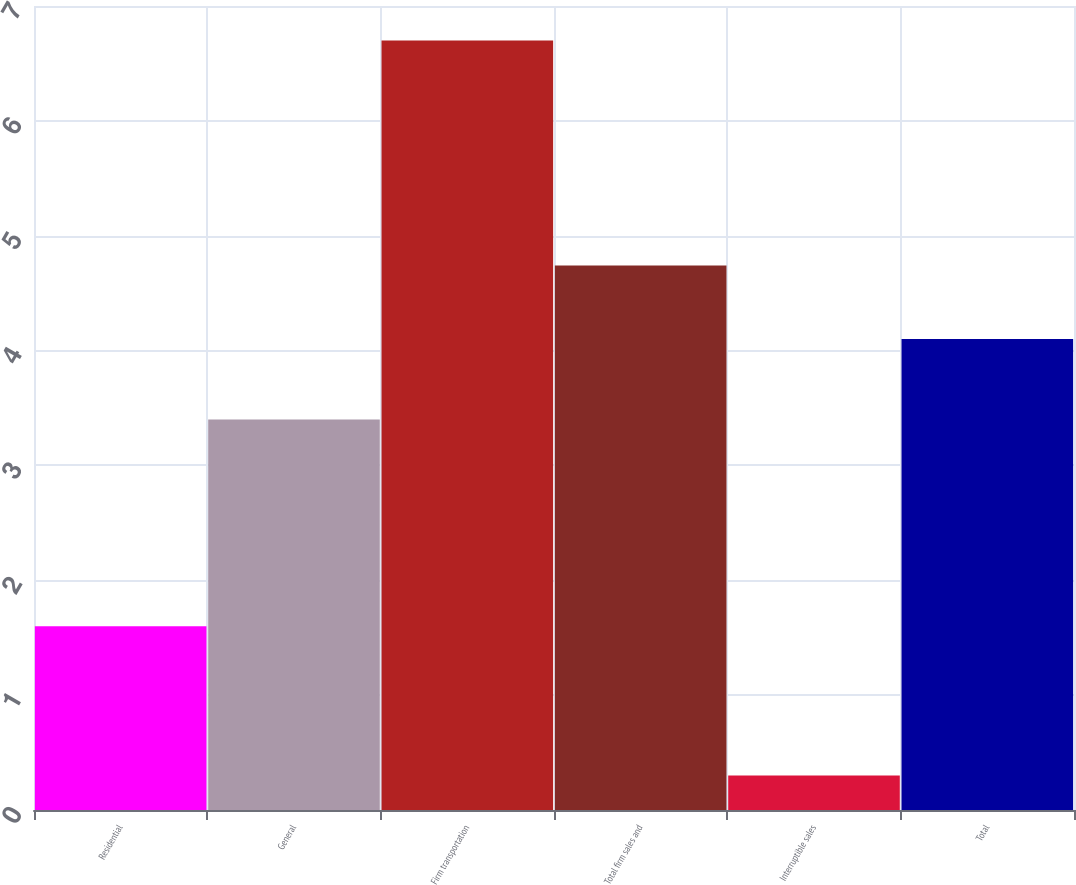Convert chart to OTSL. <chart><loc_0><loc_0><loc_500><loc_500><bar_chart><fcel>Residential<fcel>General<fcel>Firm transportation<fcel>Total firm sales and<fcel>Interruptible sales<fcel>Total<nl><fcel>1.6<fcel>3.4<fcel>6.7<fcel>4.74<fcel>0.3<fcel>4.1<nl></chart> 